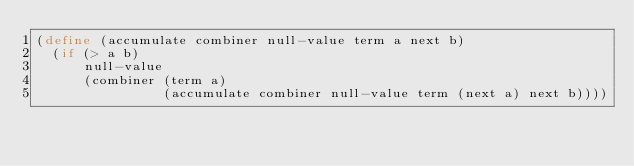Convert code to text. <code><loc_0><loc_0><loc_500><loc_500><_Scheme_>(define (accumulate combiner null-value term a next b)
  (if (> a b)
      null-value
      (combiner (term a)
                (accumulate combiner null-value term (next a) next b))))
</code> 